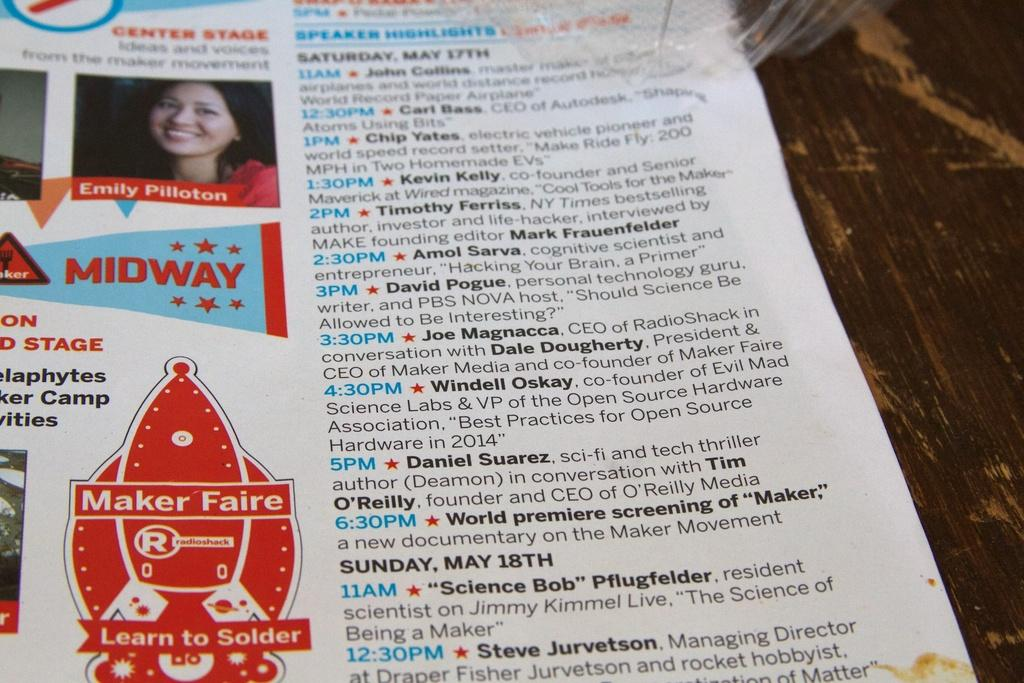What object is on the table in the image? There is a magazine on the table. What can be seen in the magazine? The magazine contains a picture of a lady smiling. Is there any text in the magazine? Yes, there is text visible in the magazine. What grade does the lady in the magazine receive for her performance? There is no mention of a grade or performance in the image, as it only shows a picture of a lady smiling in a magazine. 